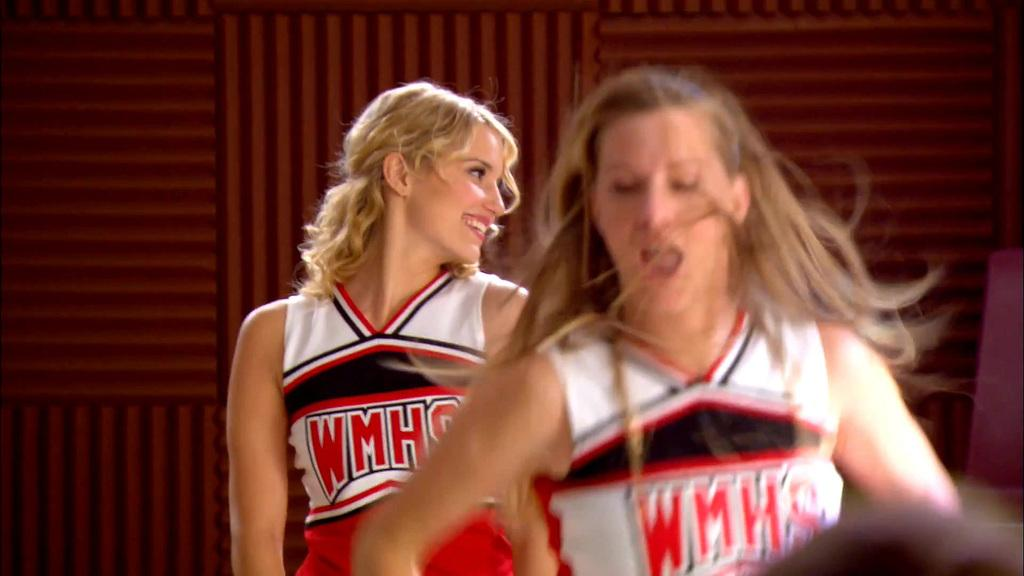<image>
Summarize the visual content of the image. Two cheerleaders are shown in red, white, and black uniforms from WMHS. 